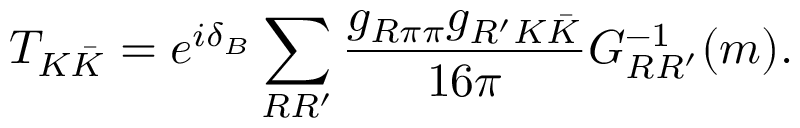<formula> <loc_0><loc_0><loc_500><loc_500>T _ { K \bar { K } } = e ^ { i \delta _ { B } } \sum _ { R R ^ { \prime } } \frac { g _ { R \pi \pi } g _ { R ^ { \prime } K \bar { K } } } { 1 6 \pi } G _ { R R ^ { \prime } } ^ { - 1 } ( m ) .</formula> 